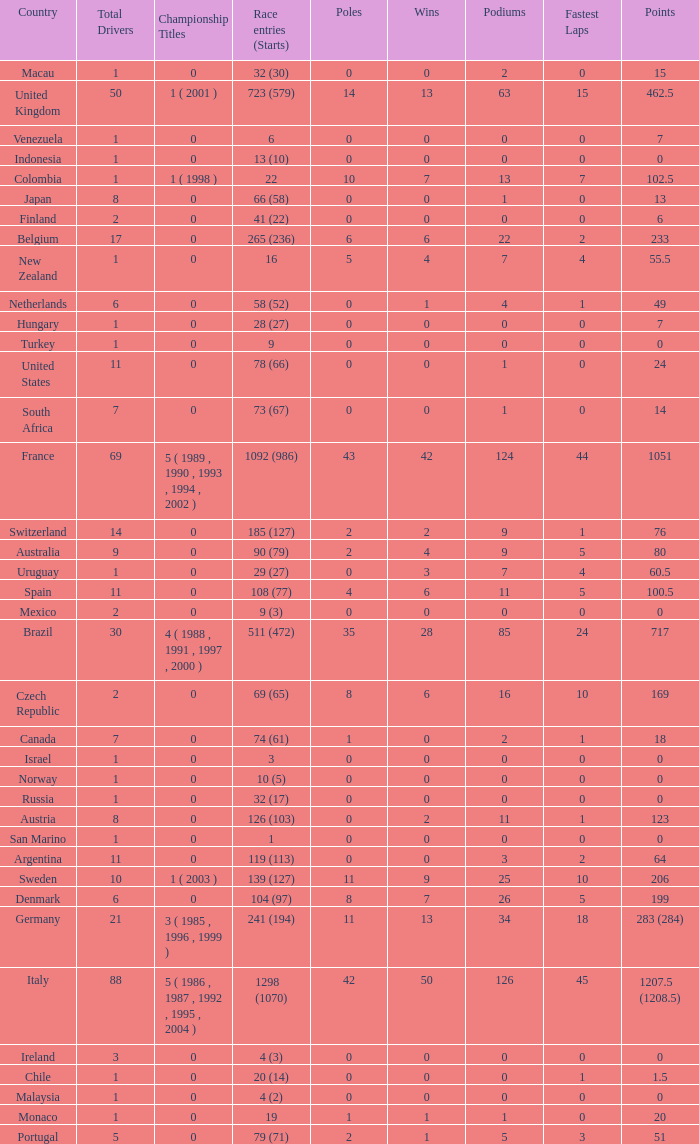How many titles for the nation with less than 3 fastest laps and 22 podiums? 0.0. 